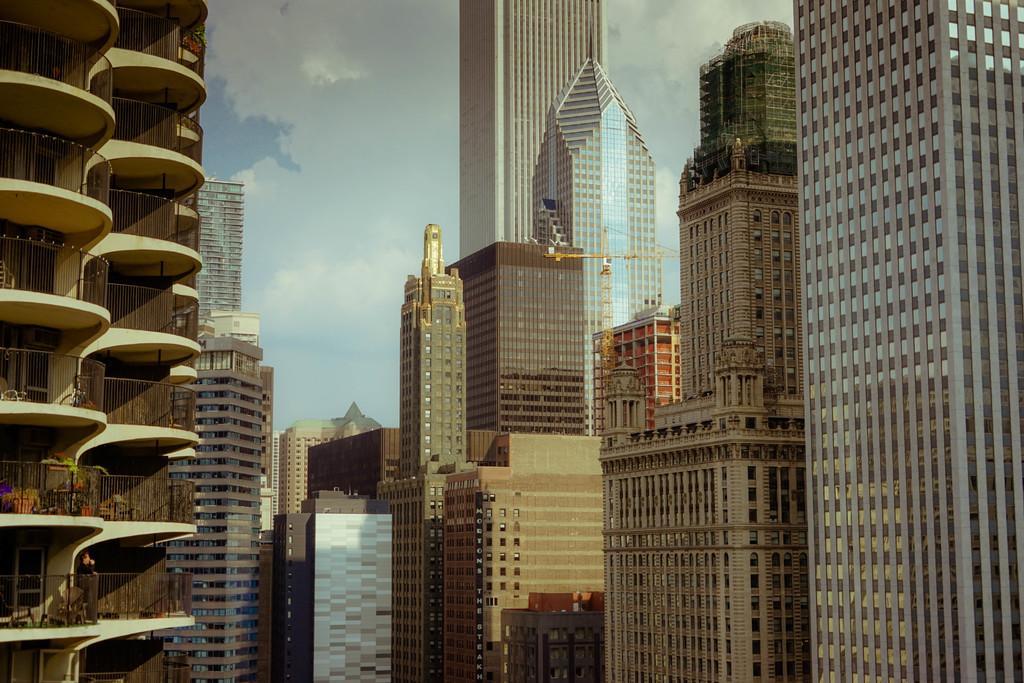Could you give a brief overview of what you see in this image? In this image I can see buildings. There are iron grilles, there is a crane, a person and in the background there is sky. 